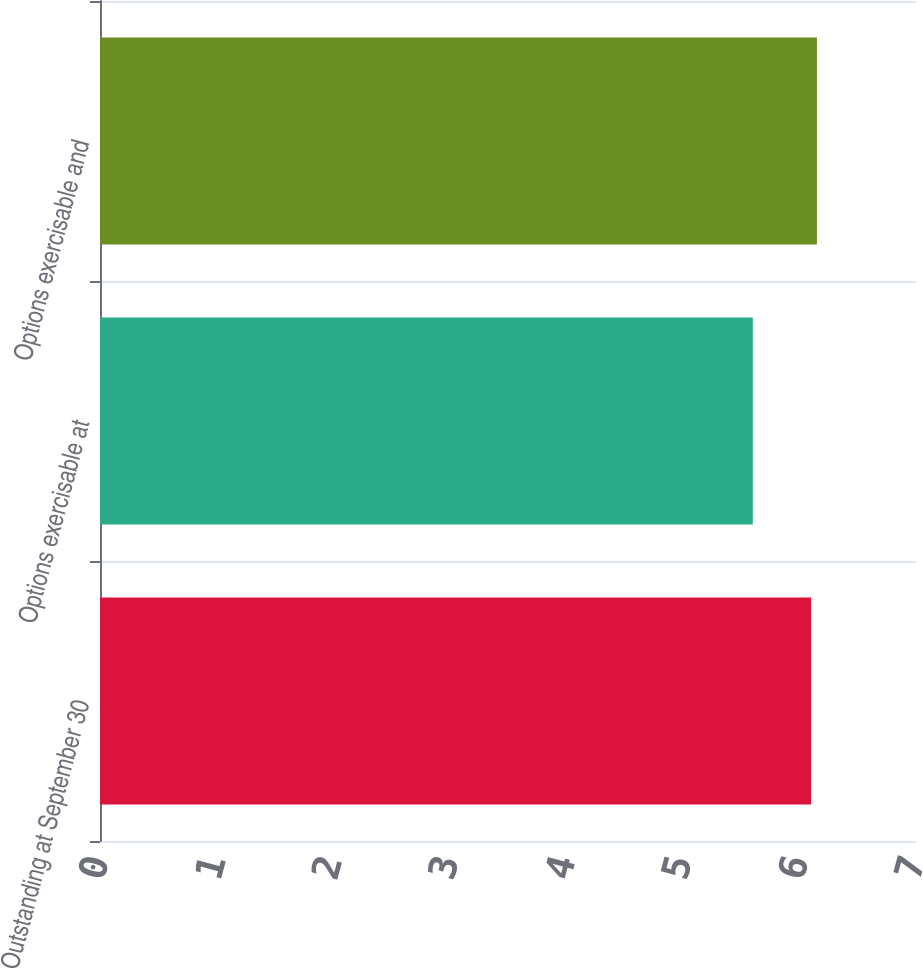Convert chart to OTSL. <chart><loc_0><loc_0><loc_500><loc_500><bar_chart><fcel>Outstanding at September 30<fcel>Options exercisable at<fcel>Options exercisable and<nl><fcel>6.1<fcel>5.6<fcel>6.15<nl></chart> 